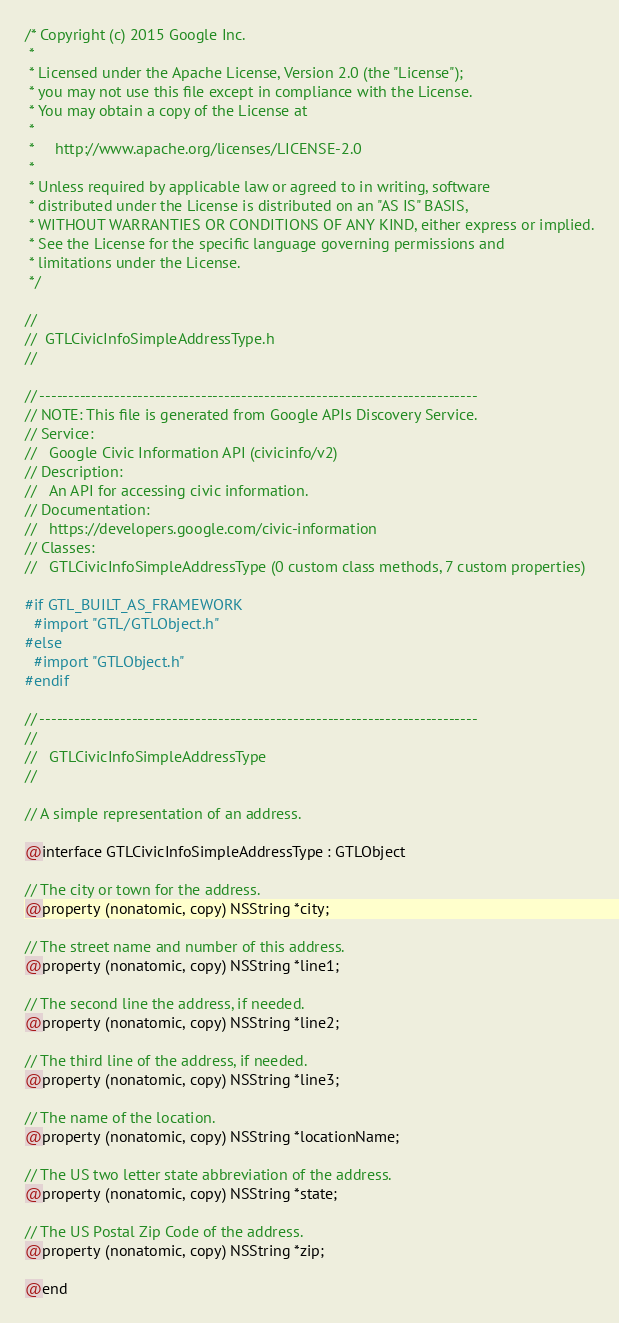Convert code to text. <code><loc_0><loc_0><loc_500><loc_500><_C_>/* Copyright (c) 2015 Google Inc.
 *
 * Licensed under the Apache License, Version 2.0 (the "License");
 * you may not use this file except in compliance with the License.
 * You may obtain a copy of the License at
 *
 *     http://www.apache.org/licenses/LICENSE-2.0
 *
 * Unless required by applicable law or agreed to in writing, software
 * distributed under the License is distributed on an "AS IS" BASIS,
 * WITHOUT WARRANTIES OR CONDITIONS OF ANY KIND, either express or implied.
 * See the License for the specific language governing permissions and
 * limitations under the License.
 */

//
//  GTLCivicInfoSimpleAddressType.h
//

// ----------------------------------------------------------------------------
// NOTE: This file is generated from Google APIs Discovery Service.
// Service:
//   Google Civic Information API (civicinfo/v2)
// Description:
//   An API for accessing civic information.
// Documentation:
//   https://developers.google.com/civic-information
// Classes:
//   GTLCivicInfoSimpleAddressType (0 custom class methods, 7 custom properties)

#if GTL_BUILT_AS_FRAMEWORK
  #import "GTL/GTLObject.h"
#else
  #import "GTLObject.h"
#endif

// ----------------------------------------------------------------------------
//
//   GTLCivicInfoSimpleAddressType
//

// A simple representation of an address.

@interface GTLCivicInfoSimpleAddressType : GTLObject

// The city or town for the address.
@property (nonatomic, copy) NSString *city;

// The street name and number of this address.
@property (nonatomic, copy) NSString *line1;

// The second line the address, if needed.
@property (nonatomic, copy) NSString *line2;

// The third line of the address, if needed.
@property (nonatomic, copy) NSString *line3;

// The name of the location.
@property (nonatomic, copy) NSString *locationName;

// The US two letter state abbreviation of the address.
@property (nonatomic, copy) NSString *state;

// The US Postal Zip Code of the address.
@property (nonatomic, copy) NSString *zip;

@end
</code> 